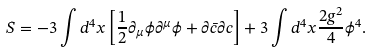Convert formula to latex. <formula><loc_0><loc_0><loc_500><loc_500>S = - 3 \int d ^ { 4 } x \left [ \frac { 1 } { 2 } \partial _ { \mu } \phi \partial ^ { \mu } \phi + \partial \bar { c } \partial c \right ] + 3 \int d ^ { 4 } x \frac { 2 g ^ { 2 } } { 4 } \phi ^ { 4 } .</formula> 